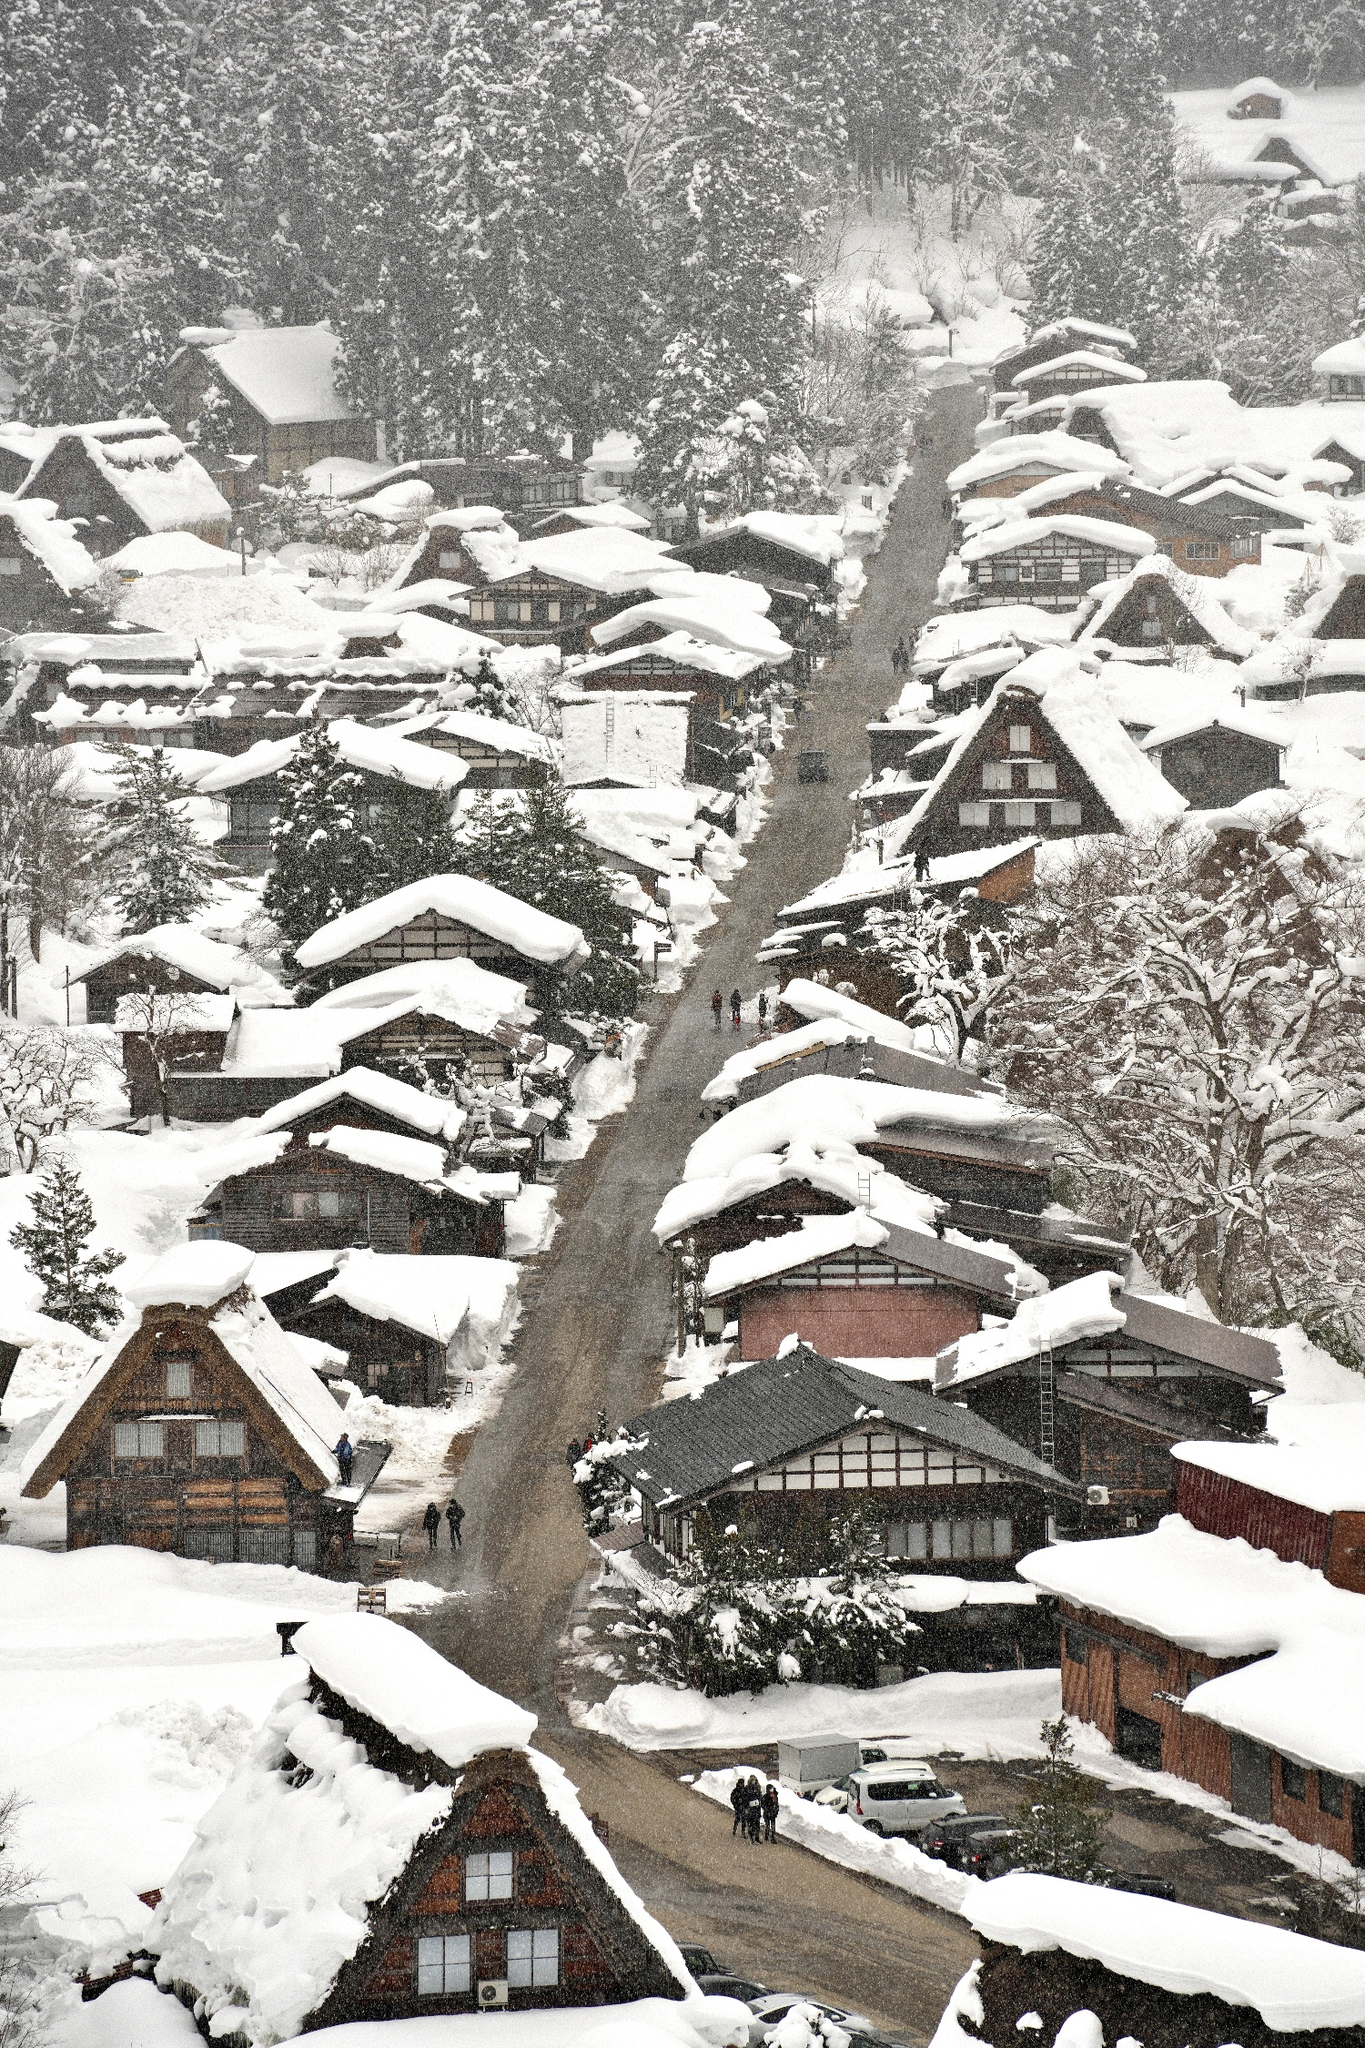Can you describe the architecture seen in this village? Certainly! The architecture in this image is characteristic of Shirakawa-go's gassho-zukuri farmhouses. These structures are noted for their steep thatched roofs that resemble hands in prayer, which is what 'gassho-zukuri' literally translates to. The design is not only culturally unique but also practical, allowing heavy snow to slide off easily, preventing damage during the heavy winters common in this region. 